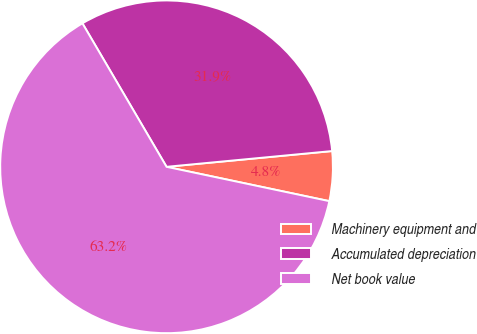Convert chart. <chart><loc_0><loc_0><loc_500><loc_500><pie_chart><fcel>Machinery equipment and<fcel>Accumulated depreciation<fcel>Net book value<nl><fcel>4.82%<fcel>31.93%<fcel>63.25%<nl></chart> 